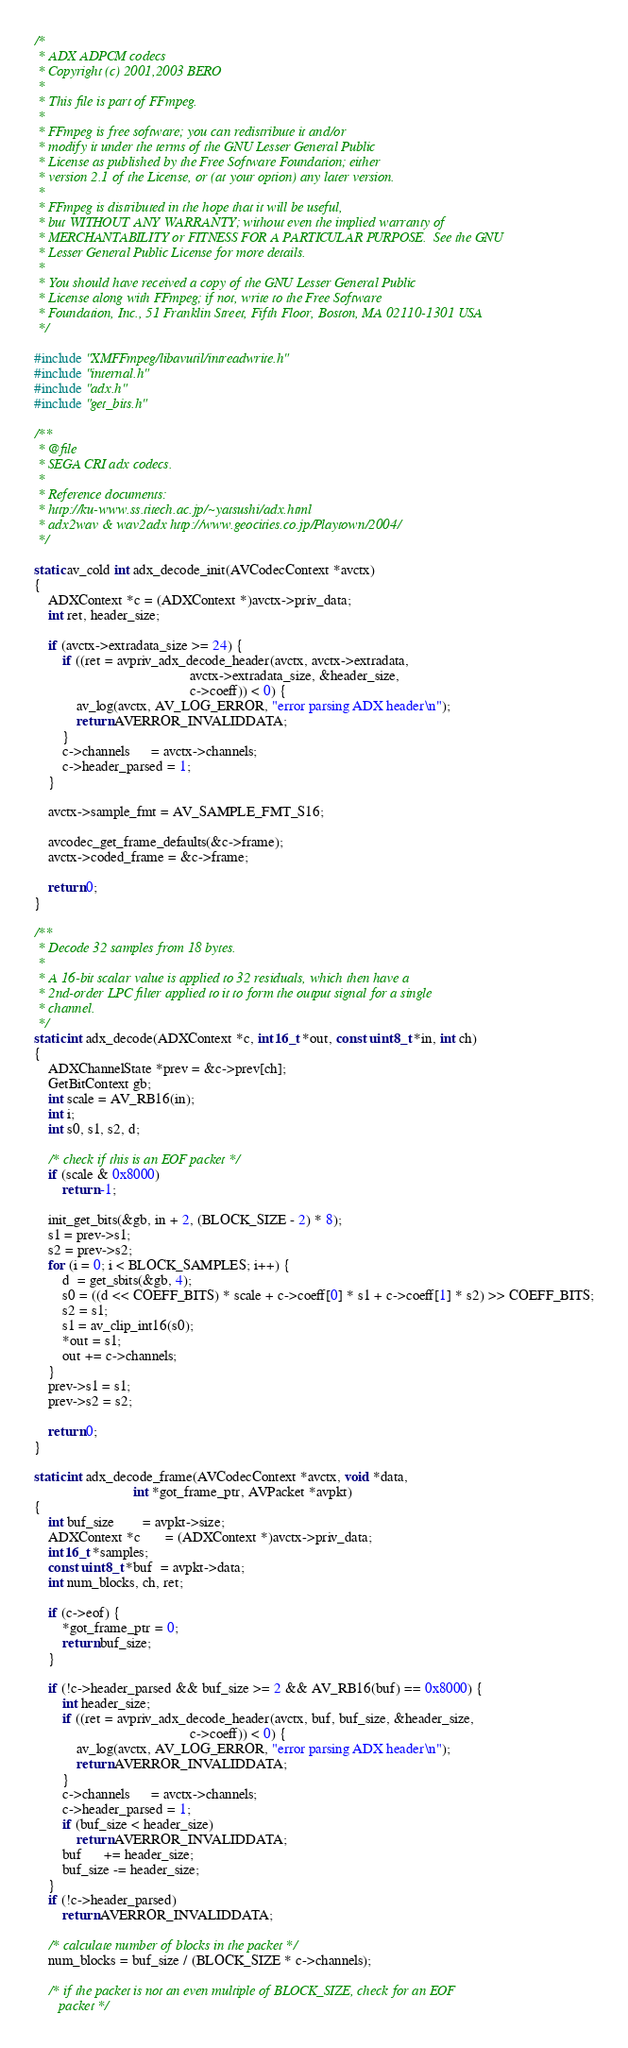<code> <loc_0><loc_0><loc_500><loc_500><_C++_>/*
 * ADX ADPCM codecs
 * Copyright (c) 2001,2003 BERO
 *
 * This file is part of FFmpeg.
 *
 * FFmpeg is free software; you can redistribute it and/or
 * modify it under the terms of the GNU Lesser General Public
 * License as published by the Free Software Foundation; either
 * version 2.1 of the License, or (at your option) any later version.
 *
 * FFmpeg is distributed in the hope that it will be useful,
 * but WITHOUT ANY WARRANTY; without even the implied warranty of
 * MERCHANTABILITY or FITNESS FOR A PARTICULAR PURPOSE.  See the GNU
 * Lesser General Public License for more details.
 *
 * You should have received a copy of the GNU Lesser General Public
 * License along with FFmpeg; if not, write to the Free Software
 * Foundation, Inc., 51 Franklin Street, Fifth Floor, Boston, MA 02110-1301 USA
 */

#include "XMFFmpeg/libavutil/intreadwrite.h"
#include "internal.h"
#include "adx.h"
#include "get_bits.h"

/**
 * @file
 * SEGA CRI adx codecs.
 *
 * Reference documents:
 * http://ku-www.ss.titech.ac.jp/~yatsushi/adx.html
 * adx2wav & wav2adx http://www.geocities.co.jp/Playtown/2004/
 */

static av_cold int adx_decode_init(AVCodecContext *avctx)
{
    ADXContext *c = (ADXContext *)avctx->priv_data;
    int ret, header_size;

    if (avctx->extradata_size >= 24) {
        if ((ret = avpriv_adx_decode_header(avctx, avctx->extradata,
                                            avctx->extradata_size, &header_size,
                                            c->coeff)) < 0) {
            av_log(avctx, AV_LOG_ERROR, "error parsing ADX header\n");
            return AVERROR_INVALIDDATA;
        }
        c->channels      = avctx->channels;
        c->header_parsed = 1;
    }

    avctx->sample_fmt = AV_SAMPLE_FMT_S16;

    avcodec_get_frame_defaults(&c->frame);
    avctx->coded_frame = &c->frame;

    return 0;
}

/**
 * Decode 32 samples from 18 bytes.
 *
 * A 16-bit scalar value is applied to 32 residuals, which then have a
 * 2nd-order LPC filter applied to it to form the output signal for a single
 * channel.
 */
static int adx_decode(ADXContext *c, int16_t *out, const uint8_t *in, int ch)
{
    ADXChannelState *prev = &c->prev[ch];
    GetBitContext gb;
    int scale = AV_RB16(in);
    int i;
    int s0, s1, s2, d;

    /* check if this is an EOF packet */
    if (scale & 0x8000)
        return -1;

    init_get_bits(&gb, in + 2, (BLOCK_SIZE - 2) * 8);
    s1 = prev->s1;
    s2 = prev->s2;
    for (i = 0; i < BLOCK_SAMPLES; i++) {
        d  = get_sbits(&gb, 4);
        s0 = ((d << COEFF_BITS) * scale + c->coeff[0] * s1 + c->coeff[1] * s2) >> COEFF_BITS;
        s2 = s1;
        s1 = av_clip_int16(s0);
        *out = s1;
        out += c->channels;
    }
    prev->s1 = s1;
    prev->s2 = s2;

    return 0;
}

static int adx_decode_frame(AVCodecContext *avctx, void *data,
                            int *got_frame_ptr, AVPacket *avpkt)
{
    int buf_size        = avpkt->size;
    ADXContext *c       = (ADXContext *)avctx->priv_data;
    int16_t *samples;
    const uint8_t *buf  = avpkt->data;
    int num_blocks, ch, ret;

    if (c->eof) {
        *got_frame_ptr = 0;
        return buf_size;
    }

    if (!c->header_parsed && buf_size >= 2 && AV_RB16(buf) == 0x8000) {
        int header_size;
        if ((ret = avpriv_adx_decode_header(avctx, buf, buf_size, &header_size,
                                            c->coeff)) < 0) {
            av_log(avctx, AV_LOG_ERROR, "error parsing ADX header\n");
            return AVERROR_INVALIDDATA;
        }
        c->channels      = avctx->channels;
        c->header_parsed = 1;
        if (buf_size < header_size)
            return AVERROR_INVALIDDATA;
        buf      += header_size;
        buf_size -= header_size;
    }
    if (!c->header_parsed)
        return AVERROR_INVALIDDATA;

    /* calculate number of blocks in the packet */
    num_blocks = buf_size / (BLOCK_SIZE * c->channels);

    /* if the packet is not an even multiple of BLOCK_SIZE, check for an EOF
       packet */</code> 